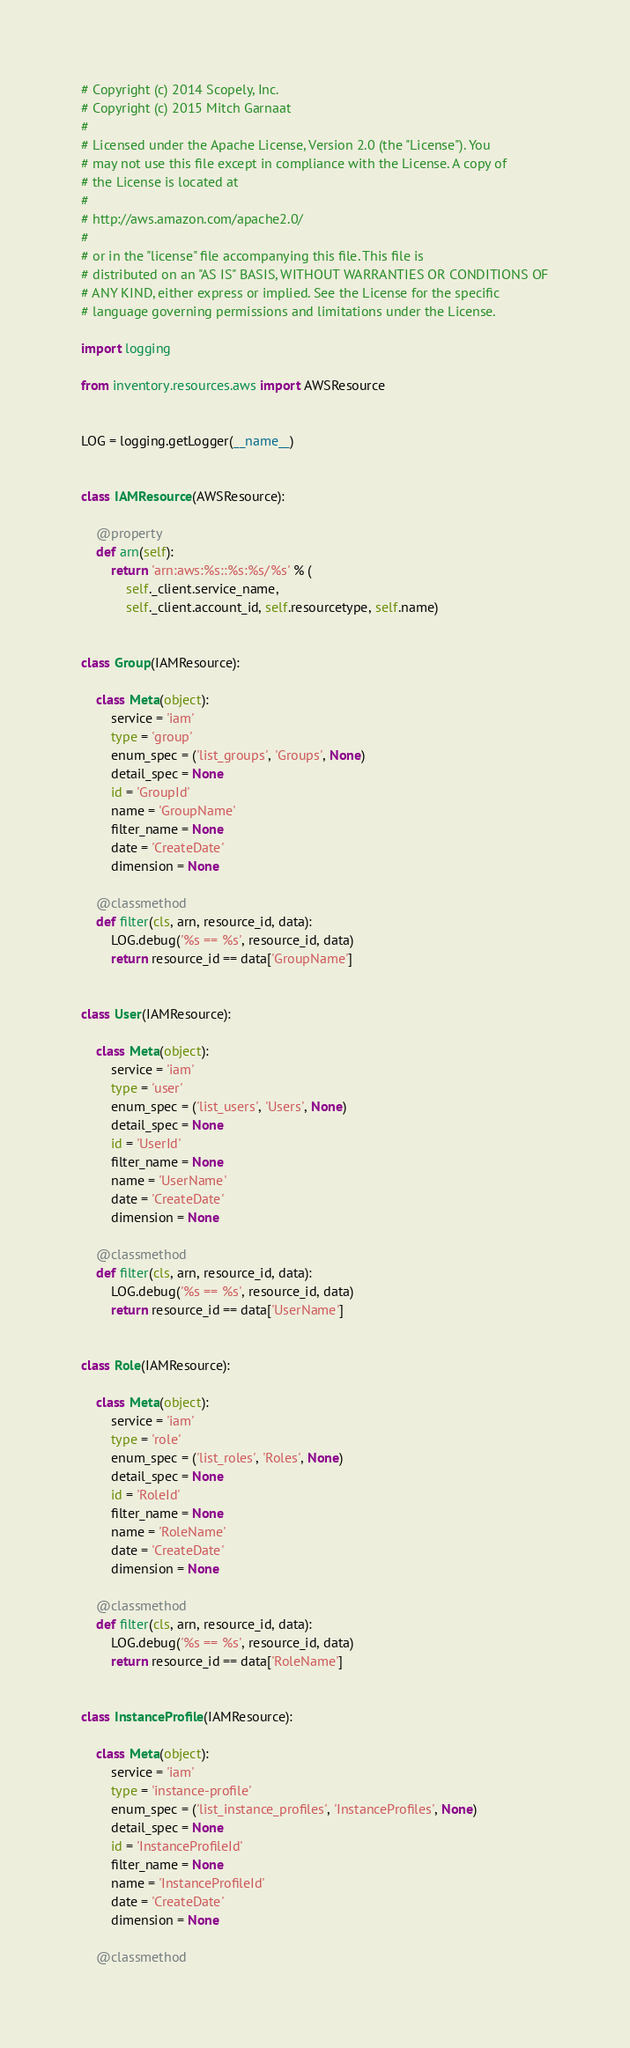Convert code to text. <code><loc_0><loc_0><loc_500><loc_500><_Python_># Copyright (c) 2014 Scopely, Inc.
# Copyright (c) 2015 Mitch Garnaat
#
# Licensed under the Apache License, Version 2.0 (the "License"). You
# may not use this file except in compliance with the License. A copy of
# the License is located at
#
# http://aws.amazon.com/apache2.0/
#
# or in the "license" file accompanying this file. This file is
# distributed on an "AS IS" BASIS, WITHOUT WARRANTIES OR CONDITIONS OF
# ANY KIND, either express or implied. See the License for the specific
# language governing permissions and limitations under the License.

import logging

from inventory.resources.aws import AWSResource


LOG = logging.getLogger(__name__)


class IAMResource(AWSResource):

    @property
    def arn(self):
        return 'arn:aws:%s::%s:%s/%s' % (
            self._client.service_name,
            self._client.account_id, self.resourcetype, self.name)


class Group(IAMResource):

    class Meta(object):
        service = 'iam'
        type = 'group'
        enum_spec = ('list_groups', 'Groups', None)
        detail_spec = None
        id = 'GroupId'
        name = 'GroupName'
        filter_name = None
        date = 'CreateDate'
        dimension = None

    @classmethod
    def filter(cls, arn, resource_id, data):
        LOG.debug('%s == %s', resource_id, data)
        return resource_id == data['GroupName']


class User(IAMResource):

    class Meta(object):
        service = 'iam'
        type = 'user'
        enum_spec = ('list_users', 'Users', None)
        detail_spec = None
        id = 'UserId'
        filter_name = None
        name = 'UserName'
        date = 'CreateDate'
        dimension = None

    @classmethod
    def filter(cls, arn, resource_id, data):
        LOG.debug('%s == %s', resource_id, data)
        return resource_id == data['UserName']


class Role(IAMResource):

    class Meta(object):
        service = 'iam'
        type = 'role'
        enum_spec = ('list_roles', 'Roles', None)
        detail_spec = None
        id = 'RoleId'
        filter_name = None
        name = 'RoleName'
        date = 'CreateDate'
        dimension = None

    @classmethod
    def filter(cls, arn, resource_id, data):
        LOG.debug('%s == %s', resource_id, data)
        return resource_id == data['RoleName']


class InstanceProfile(IAMResource):

    class Meta(object):
        service = 'iam'
        type = 'instance-profile'
        enum_spec = ('list_instance_profiles', 'InstanceProfiles', None)
        detail_spec = None
        id = 'InstanceProfileId'
        filter_name = None
        name = 'InstanceProfileId'
        date = 'CreateDate'
        dimension = None

    @classmethod</code> 